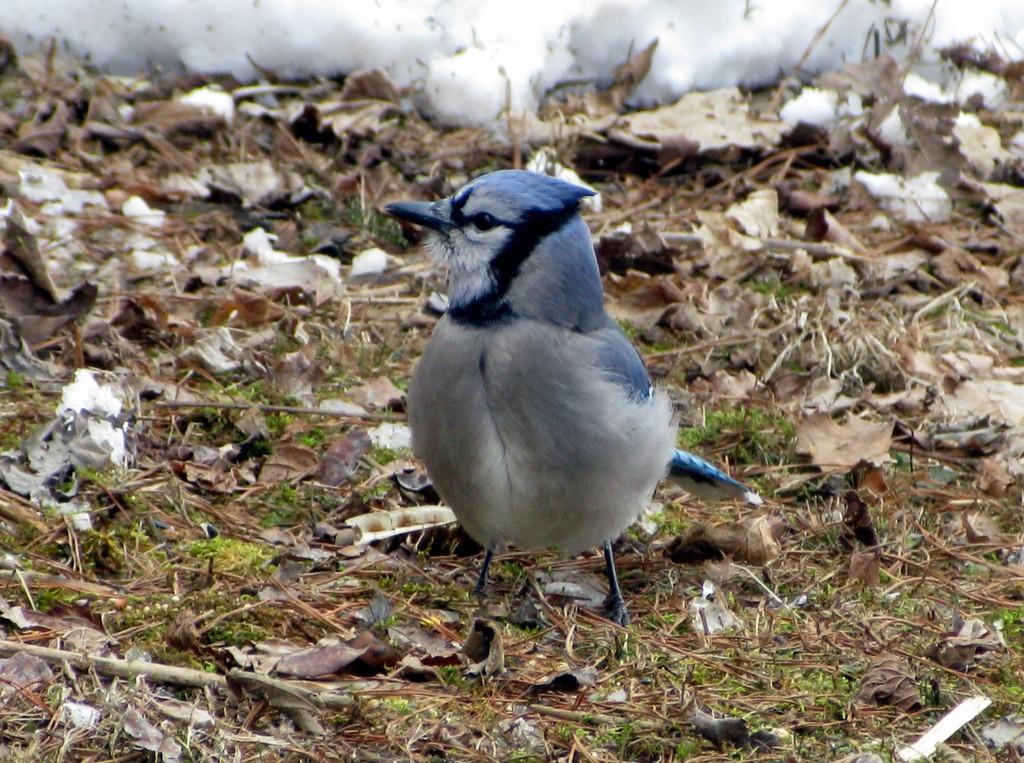Can you describe this image briefly? In this picture there is a grey and white color small bird sitting on the ground. In the front there are some dry leaves on the ground. 